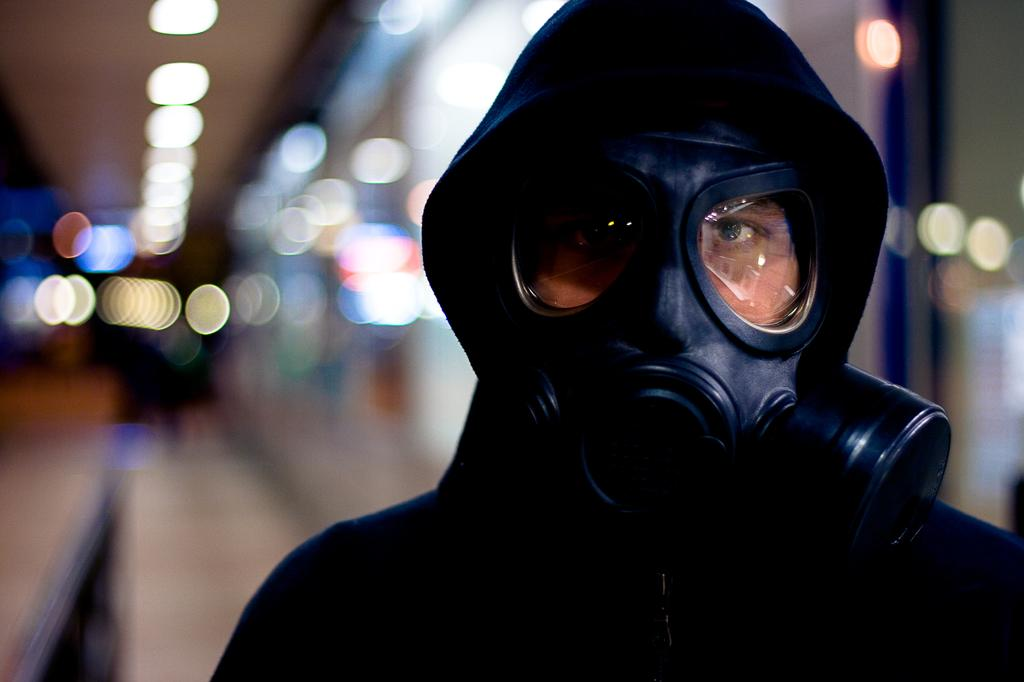Who or what is present in the image? There is a person in the image. What is the person wearing? The person is wearing a mask. What can be seen in the background of the image? There is a light focus visible in the background of the image. How many horses are present in the image? There are no horses present in the image; it features a person wearing a mask. Who is the representative of the group in the image? The image does not depict a group or a representative; it only shows a person wearing a mask. 